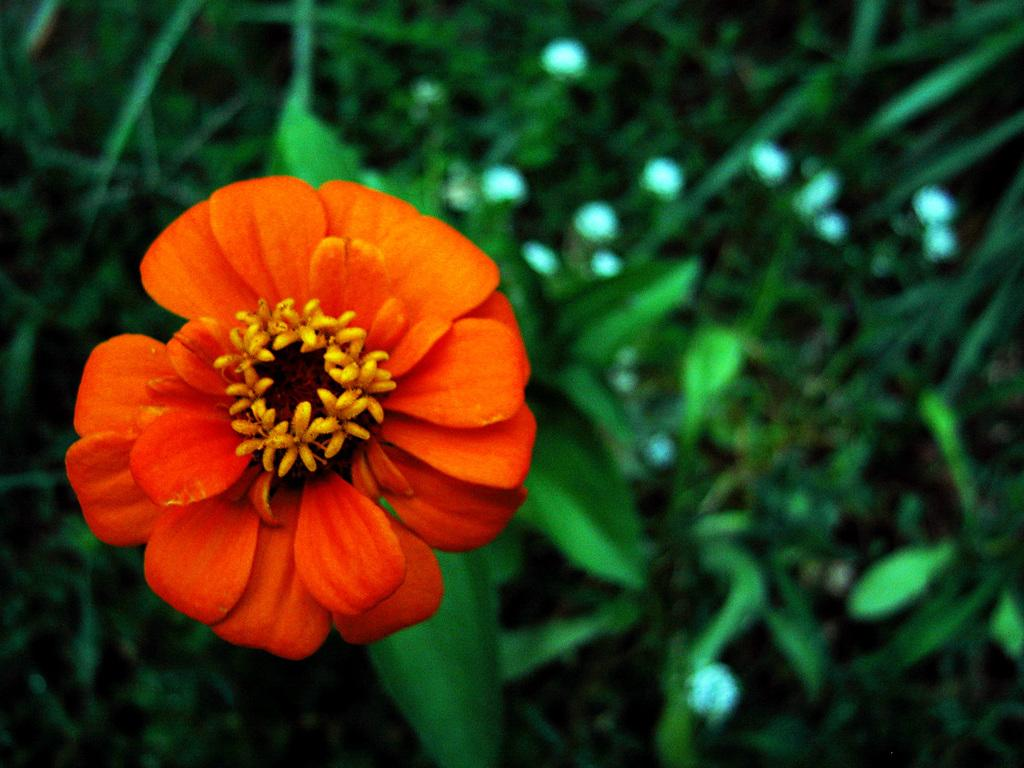What color is the flower on the left side of the image? The flower on the left side of the image is orange. What can be seen in the background of the image? There are leaves in the background of the image. How many attempts were made to sort the middle section of the image? There is no sorting or middle section present in the image, as it only features an orange flower and leaves in the background. 